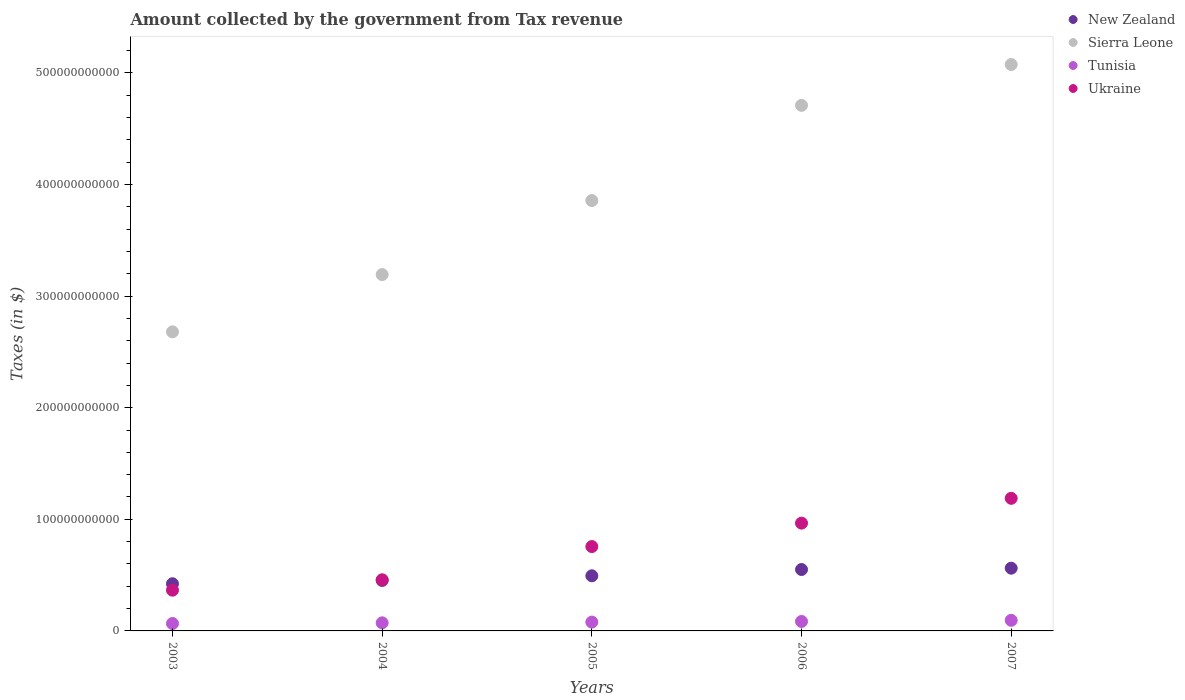How many different coloured dotlines are there?
Ensure brevity in your answer.  4. What is the amount collected by the government from tax revenue in Tunisia in 2005?
Your answer should be very brief. 7.90e+09. Across all years, what is the maximum amount collected by the government from tax revenue in Sierra Leone?
Offer a very short reply. 5.07e+11. Across all years, what is the minimum amount collected by the government from tax revenue in Tunisia?
Provide a succinct answer. 6.63e+09. In which year was the amount collected by the government from tax revenue in Ukraine maximum?
Provide a short and direct response. 2007. What is the total amount collected by the government from tax revenue in Ukraine in the graph?
Your answer should be very brief. 3.73e+11. What is the difference between the amount collected by the government from tax revenue in Sierra Leone in 2003 and that in 2005?
Offer a terse response. -1.18e+11. What is the difference between the amount collected by the government from tax revenue in Tunisia in 2003 and the amount collected by the government from tax revenue in New Zealand in 2007?
Give a very brief answer. -4.96e+1. What is the average amount collected by the government from tax revenue in New Zealand per year?
Keep it short and to the point. 4.96e+1. In the year 2006, what is the difference between the amount collected by the government from tax revenue in Ukraine and amount collected by the government from tax revenue in Tunisia?
Your answer should be compact. 8.81e+1. What is the ratio of the amount collected by the government from tax revenue in Tunisia in 2005 to that in 2006?
Provide a short and direct response. 0.93. Is the amount collected by the government from tax revenue in Sierra Leone in 2006 less than that in 2007?
Make the answer very short. Yes. Is the difference between the amount collected by the government from tax revenue in Ukraine in 2005 and 2007 greater than the difference between the amount collected by the government from tax revenue in Tunisia in 2005 and 2007?
Keep it short and to the point. No. What is the difference between the highest and the second highest amount collected by the government from tax revenue in Ukraine?
Your answer should be compact. 2.22e+1. What is the difference between the highest and the lowest amount collected by the government from tax revenue in New Zealand?
Your answer should be compact. 1.39e+1. In how many years, is the amount collected by the government from tax revenue in Ukraine greater than the average amount collected by the government from tax revenue in Ukraine taken over all years?
Offer a terse response. 3. Is the sum of the amount collected by the government from tax revenue in Tunisia in 2004 and 2005 greater than the maximum amount collected by the government from tax revenue in Sierra Leone across all years?
Provide a succinct answer. No. Is the amount collected by the government from tax revenue in Ukraine strictly greater than the amount collected by the government from tax revenue in Sierra Leone over the years?
Your answer should be very brief. No. How many dotlines are there?
Your answer should be compact. 4. What is the difference between two consecutive major ticks on the Y-axis?
Offer a very short reply. 1.00e+11. Are the values on the major ticks of Y-axis written in scientific E-notation?
Offer a very short reply. No. Does the graph contain any zero values?
Ensure brevity in your answer.  No. Does the graph contain grids?
Provide a succinct answer. No. Where does the legend appear in the graph?
Offer a terse response. Top right. How many legend labels are there?
Offer a terse response. 4. How are the legend labels stacked?
Keep it short and to the point. Vertical. What is the title of the graph?
Your response must be concise. Amount collected by the government from Tax revenue. What is the label or title of the Y-axis?
Make the answer very short. Taxes (in $). What is the Taxes (in $) of New Zealand in 2003?
Ensure brevity in your answer.  4.23e+1. What is the Taxes (in $) of Sierra Leone in 2003?
Offer a very short reply. 2.68e+11. What is the Taxes (in $) of Tunisia in 2003?
Your answer should be very brief. 6.63e+09. What is the Taxes (in $) in Ukraine in 2003?
Your response must be concise. 3.65e+1. What is the Taxes (in $) of New Zealand in 2004?
Provide a succinct answer. 4.52e+1. What is the Taxes (in $) in Sierra Leone in 2004?
Provide a short and direct response. 3.19e+11. What is the Taxes (in $) of Tunisia in 2004?
Your response must be concise. 7.25e+09. What is the Taxes (in $) in Ukraine in 2004?
Give a very brief answer. 4.58e+1. What is the Taxes (in $) of New Zealand in 2005?
Offer a terse response. 4.94e+1. What is the Taxes (in $) of Sierra Leone in 2005?
Your answer should be compact. 3.86e+11. What is the Taxes (in $) in Tunisia in 2005?
Ensure brevity in your answer.  7.90e+09. What is the Taxes (in $) of Ukraine in 2005?
Give a very brief answer. 7.56e+1. What is the Taxes (in $) in New Zealand in 2006?
Keep it short and to the point. 5.50e+1. What is the Taxes (in $) of Sierra Leone in 2006?
Offer a terse response. 4.71e+11. What is the Taxes (in $) in Tunisia in 2006?
Provide a short and direct response. 8.47e+09. What is the Taxes (in $) of Ukraine in 2006?
Offer a very short reply. 9.66e+1. What is the Taxes (in $) in New Zealand in 2007?
Offer a terse response. 5.62e+1. What is the Taxes (in $) in Sierra Leone in 2007?
Keep it short and to the point. 5.07e+11. What is the Taxes (in $) in Tunisia in 2007?
Give a very brief answer. 9.51e+09. What is the Taxes (in $) of Ukraine in 2007?
Ensure brevity in your answer.  1.19e+11. Across all years, what is the maximum Taxes (in $) of New Zealand?
Ensure brevity in your answer.  5.62e+1. Across all years, what is the maximum Taxes (in $) of Sierra Leone?
Your answer should be very brief. 5.07e+11. Across all years, what is the maximum Taxes (in $) of Tunisia?
Offer a very short reply. 9.51e+09. Across all years, what is the maximum Taxes (in $) in Ukraine?
Ensure brevity in your answer.  1.19e+11. Across all years, what is the minimum Taxes (in $) in New Zealand?
Provide a succinct answer. 4.23e+1. Across all years, what is the minimum Taxes (in $) in Sierra Leone?
Provide a succinct answer. 2.68e+11. Across all years, what is the minimum Taxes (in $) of Tunisia?
Offer a very short reply. 6.63e+09. Across all years, what is the minimum Taxes (in $) in Ukraine?
Keep it short and to the point. 3.65e+1. What is the total Taxes (in $) of New Zealand in the graph?
Make the answer very short. 2.48e+11. What is the total Taxes (in $) in Sierra Leone in the graph?
Offer a very short reply. 1.95e+12. What is the total Taxes (in $) in Tunisia in the graph?
Keep it short and to the point. 3.98e+1. What is the total Taxes (in $) of Ukraine in the graph?
Keep it short and to the point. 3.73e+11. What is the difference between the Taxes (in $) in New Zealand in 2003 and that in 2004?
Keep it short and to the point. -2.96e+09. What is the difference between the Taxes (in $) of Sierra Leone in 2003 and that in 2004?
Offer a very short reply. -5.13e+1. What is the difference between the Taxes (in $) of Tunisia in 2003 and that in 2004?
Make the answer very short. -6.21e+08. What is the difference between the Taxes (in $) of Ukraine in 2003 and that in 2004?
Your answer should be very brief. -9.31e+09. What is the difference between the Taxes (in $) of New Zealand in 2003 and that in 2005?
Make the answer very short. -7.13e+09. What is the difference between the Taxes (in $) in Sierra Leone in 2003 and that in 2005?
Make the answer very short. -1.18e+11. What is the difference between the Taxes (in $) of Tunisia in 2003 and that in 2005?
Make the answer very short. -1.27e+09. What is the difference between the Taxes (in $) of Ukraine in 2003 and that in 2005?
Provide a succinct answer. -3.91e+1. What is the difference between the Taxes (in $) of New Zealand in 2003 and that in 2006?
Provide a short and direct response. -1.28e+1. What is the difference between the Taxes (in $) of Sierra Leone in 2003 and that in 2006?
Provide a short and direct response. -2.03e+11. What is the difference between the Taxes (in $) in Tunisia in 2003 and that in 2006?
Give a very brief answer. -1.84e+09. What is the difference between the Taxes (in $) of Ukraine in 2003 and that in 2006?
Offer a very short reply. -6.01e+1. What is the difference between the Taxes (in $) in New Zealand in 2003 and that in 2007?
Keep it short and to the point. -1.39e+1. What is the difference between the Taxes (in $) in Sierra Leone in 2003 and that in 2007?
Ensure brevity in your answer.  -2.40e+11. What is the difference between the Taxes (in $) of Tunisia in 2003 and that in 2007?
Make the answer very short. -2.88e+09. What is the difference between the Taxes (in $) in Ukraine in 2003 and that in 2007?
Offer a terse response. -8.23e+1. What is the difference between the Taxes (in $) in New Zealand in 2004 and that in 2005?
Offer a very short reply. -4.17e+09. What is the difference between the Taxes (in $) of Sierra Leone in 2004 and that in 2005?
Your answer should be very brief. -6.63e+1. What is the difference between the Taxes (in $) in Tunisia in 2004 and that in 2005?
Give a very brief answer. -6.52e+08. What is the difference between the Taxes (in $) of Ukraine in 2004 and that in 2005?
Make the answer very short. -2.98e+1. What is the difference between the Taxes (in $) of New Zealand in 2004 and that in 2006?
Offer a terse response. -9.80e+09. What is the difference between the Taxes (in $) in Sierra Leone in 2004 and that in 2006?
Give a very brief answer. -1.52e+11. What is the difference between the Taxes (in $) of Tunisia in 2004 and that in 2006?
Your answer should be compact. -1.22e+09. What is the difference between the Taxes (in $) of Ukraine in 2004 and that in 2006?
Make the answer very short. -5.08e+1. What is the difference between the Taxes (in $) in New Zealand in 2004 and that in 2007?
Your answer should be compact. -1.10e+1. What is the difference between the Taxes (in $) of Sierra Leone in 2004 and that in 2007?
Make the answer very short. -1.88e+11. What is the difference between the Taxes (in $) of Tunisia in 2004 and that in 2007?
Provide a short and direct response. -2.26e+09. What is the difference between the Taxes (in $) in Ukraine in 2004 and that in 2007?
Provide a succinct answer. -7.30e+1. What is the difference between the Taxes (in $) in New Zealand in 2005 and that in 2006?
Offer a terse response. -5.63e+09. What is the difference between the Taxes (in $) in Sierra Leone in 2005 and that in 2006?
Your answer should be very brief. -8.53e+1. What is the difference between the Taxes (in $) of Tunisia in 2005 and that in 2006?
Keep it short and to the point. -5.66e+08. What is the difference between the Taxes (in $) in Ukraine in 2005 and that in 2006?
Your answer should be very brief. -2.10e+1. What is the difference between the Taxes (in $) of New Zealand in 2005 and that in 2007?
Your answer should be compact. -6.82e+09. What is the difference between the Taxes (in $) of Sierra Leone in 2005 and that in 2007?
Provide a short and direct response. -1.22e+11. What is the difference between the Taxes (in $) in Tunisia in 2005 and that in 2007?
Offer a terse response. -1.60e+09. What is the difference between the Taxes (in $) of Ukraine in 2005 and that in 2007?
Offer a terse response. -4.32e+1. What is the difference between the Taxes (in $) in New Zealand in 2006 and that in 2007?
Make the answer very short. -1.19e+09. What is the difference between the Taxes (in $) in Sierra Leone in 2006 and that in 2007?
Your response must be concise. -3.66e+1. What is the difference between the Taxes (in $) in Tunisia in 2006 and that in 2007?
Ensure brevity in your answer.  -1.04e+09. What is the difference between the Taxes (in $) of Ukraine in 2006 and that in 2007?
Your answer should be compact. -2.22e+1. What is the difference between the Taxes (in $) of New Zealand in 2003 and the Taxes (in $) of Sierra Leone in 2004?
Offer a very short reply. -2.77e+11. What is the difference between the Taxes (in $) in New Zealand in 2003 and the Taxes (in $) in Tunisia in 2004?
Keep it short and to the point. 3.50e+1. What is the difference between the Taxes (in $) of New Zealand in 2003 and the Taxes (in $) of Ukraine in 2004?
Keep it short and to the point. -3.55e+09. What is the difference between the Taxes (in $) in Sierra Leone in 2003 and the Taxes (in $) in Tunisia in 2004?
Your answer should be compact. 2.61e+11. What is the difference between the Taxes (in $) of Sierra Leone in 2003 and the Taxes (in $) of Ukraine in 2004?
Give a very brief answer. 2.22e+11. What is the difference between the Taxes (in $) of Tunisia in 2003 and the Taxes (in $) of Ukraine in 2004?
Make the answer very short. -3.92e+1. What is the difference between the Taxes (in $) of New Zealand in 2003 and the Taxes (in $) of Sierra Leone in 2005?
Keep it short and to the point. -3.43e+11. What is the difference between the Taxes (in $) of New Zealand in 2003 and the Taxes (in $) of Tunisia in 2005?
Ensure brevity in your answer.  3.44e+1. What is the difference between the Taxes (in $) of New Zealand in 2003 and the Taxes (in $) of Ukraine in 2005?
Ensure brevity in your answer.  -3.33e+1. What is the difference between the Taxes (in $) in Sierra Leone in 2003 and the Taxes (in $) in Tunisia in 2005?
Offer a terse response. 2.60e+11. What is the difference between the Taxes (in $) in Sierra Leone in 2003 and the Taxes (in $) in Ukraine in 2005?
Keep it short and to the point. 1.92e+11. What is the difference between the Taxes (in $) in Tunisia in 2003 and the Taxes (in $) in Ukraine in 2005?
Your response must be concise. -6.90e+1. What is the difference between the Taxes (in $) in New Zealand in 2003 and the Taxes (in $) in Sierra Leone in 2006?
Offer a very short reply. -4.29e+11. What is the difference between the Taxes (in $) in New Zealand in 2003 and the Taxes (in $) in Tunisia in 2006?
Offer a very short reply. 3.38e+1. What is the difference between the Taxes (in $) in New Zealand in 2003 and the Taxes (in $) in Ukraine in 2006?
Offer a very short reply. -5.43e+1. What is the difference between the Taxes (in $) in Sierra Leone in 2003 and the Taxes (in $) in Tunisia in 2006?
Ensure brevity in your answer.  2.59e+11. What is the difference between the Taxes (in $) in Sierra Leone in 2003 and the Taxes (in $) in Ukraine in 2006?
Offer a terse response. 1.71e+11. What is the difference between the Taxes (in $) in Tunisia in 2003 and the Taxes (in $) in Ukraine in 2006?
Give a very brief answer. -8.99e+1. What is the difference between the Taxes (in $) of New Zealand in 2003 and the Taxes (in $) of Sierra Leone in 2007?
Offer a terse response. -4.65e+11. What is the difference between the Taxes (in $) of New Zealand in 2003 and the Taxes (in $) of Tunisia in 2007?
Offer a terse response. 3.28e+1. What is the difference between the Taxes (in $) in New Zealand in 2003 and the Taxes (in $) in Ukraine in 2007?
Make the answer very short. -7.65e+1. What is the difference between the Taxes (in $) in Sierra Leone in 2003 and the Taxes (in $) in Tunisia in 2007?
Your answer should be very brief. 2.58e+11. What is the difference between the Taxes (in $) in Sierra Leone in 2003 and the Taxes (in $) in Ukraine in 2007?
Keep it short and to the point. 1.49e+11. What is the difference between the Taxes (in $) of Tunisia in 2003 and the Taxes (in $) of Ukraine in 2007?
Provide a short and direct response. -1.12e+11. What is the difference between the Taxes (in $) of New Zealand in 2004 and the Taxes (in $) of Sierra Leone in 2005?
Ensure brevity in your answer.  -3.40e+11. What is the difference between the Taxes (in $) of New Zealand in 2004 and the Taxes (in $) of Tunisia in 2005?
Your answer should be compact. 3.73e+1. What is the difference between the Taxes (in $) of New Zealand in 2004 and the Taxes (in $) of Ukraine in 2005?
Give a very brief answer. -3.04e+1. What is the difference between the Taxes (in $) in Sierra Leone in 2004 and the Taxes (in $) in Tunisia in 2005?
Offer a very short reply. 3.11e+11. What is the difference between the Taxes (in $) of Sierra Leone in 2004 and the Taxes (in $) of Ukraine in 2005?
Provide a succinct answer. 2.44e+11. What is the difference between the Taxes (in $) in Tunisia in 2004 and the Taxes (in $) in Ukraine in 2005?
Give a very brief answer. -6.83e+1. What is the difference between the Taxes (in $) in New Zealand in 2004 and the Taxes (in $) in Sierra Leone in 2006?
Make the answer very short. -4.26e+11. What is the difference between the Taxes (in $) of New Zealand in 2004 and the Taxes (in $) of Tunisia in 2006?
Offer a very short reply. 3.68e+1. What is the difference between the Taxes (in $) of New Zealand in 2004 and the Taxes (in $) of Ukraine in 2006?
Give a very brief answer. -5.14e+1. What is the difference between the Taxes (in $) of Sierra Leone in 2004 and the Taxes (in $) of Tunisia in 2006?
Make the answer very short. 3.11e+11. What is the difference between the Taxes (in $) in Sierra Leone in 2004 and the Taxes (in $) in Ukraine in 2006?
Your answer should be very brief. 2.23e+11. What is the difference between the Taxes (in $) of Tunisia in 2004 and the Taxes (in $) of Ukraine in 2006?
Your answer should be very brief. -8.93e+1. What is the difference between the Taxes (in $) of New Zealand in 2004 and the Taxes (in $) of Sierra Leone in 2007?
Give a very brief answer. -4.62e+11. What is the difference between the Taxes (in $) of New Zealand in 2004 and the Taxes (in $) of Tunisia in 2007?
Your answer should be compact. 3.57e+1. What is the difference between the Taxes (in $) of New Zealand in 2004 and the Taxes (in $) of Ukraine in 2007?
Offer a terse response. -7.36e+1. What is the difference between the Taxes (in $) in Sierra Leone in 2004 and the Taxes (in $) in Tunisia in 2007?
Ensure brevity in your answer.  3.10e+11. What is the difference between the Taxes (in $) of Sierra Leone in 2004 and the Taxes (in $) of Ukraine in 2007?
Your answer should be very brief. 2.00e+11. What is the difference between the Taxes (in $) in Tunisia in 2004 and the Taxes (in $) in Ukraine in 2007?
Give a very brief answer. -1.12e+11. What is the difference between the Taxes (in $) of New Zealand in 2005 and the Taxes (in $) of Sierra Leone in 2006?
Make the answer very short. -4.22e+11. What is the difference between the Taxes (in $) of New Zealand in 2005 and the Taxes (in $) of Tunisia in 2006?
Your answer should be compact. 4.09e+1. What is the difference between the Taxes (in $) of New Zealand in 2005 and the Taxes (in $) of Ukraine in 2006?
Ensure brevity in your answer.  -4.72e+1. What is the difference between the Taxes (in $) in Sierra Leone in 2005 and the Taxes (in $) in Tunisia in 2006?
Your response must be concise. 3.77e+11. What is the difference between the Taxes (in $) of Sierra Leone in 2005 and the Taxes (in $) of Ukraine in 2006?
Make the answer very short. 2.89e+11. What is the difference between the Taxes (in $) in Tunisia in 2005 and the Taxes (in $) in Ukraine in 2006?
Offer a very short reply. -8.87e+1. What is the difference between the Taxes (in $) of New Zealand in 2005 and the Taxes (in $) of Sierra Leone in 2007?
Offer a very short reply. -4.58e+11. What is the difference between the Taxes (in $) in New Zealand in 2005 and the Taxes (in $) in Tunisia in 2007?
Provide a succinct answer. 3.99e+1. What is the difference between the Taxes (in $) of New Zealand in 2005 and the Taxes (in $) of Ukraine in 2007?
Your answer should be compact. -6.94e+1. What is the difference between the Taxes (in $) of Sierra Leone in 2005 and the Taxes (in $) of Tunisia in 2007?
Make the answer very short. 3.76e+11. What is the difference between the Taxes (in $) of Sierra Leone in 2005 and the Taxes (in $) of Ukraine in 2007?
Offer a terse response. 2.67e+11. What is the difference between the Taxes (in $) of Tunisia in 2005 and the Taxes (in $) of Ukraine in 2007?
Keep it short and to the point. -1.11e+11. What is the difference between the Taxes (in $) of New Zealand in 2006 and the Taxes (in $) of Sierra Leone in 2007?
Ensure brevity in your answer.  -4.52e+11. What is the difference between the Taxes (in $) in New Zealand in 2006 and the Taxes (in $) in Tunisia in 2007?
Provide a short and direct response. 4.55e+1. What is the difference between the Taxes (in $) of New Zealand in 2006 and the Taxes (in $) of Ukraine in 2007?
Your answer should be compact. -6.38e+1. What is the difference between the Taxes (in $) in Sierra Leone in 2006 and the Taxes (in $) in Tunisia in 2007?
Ensure brevity in your answer.  4.61e+11. What is the difference between the Taxes (in $) in Sierra Leone in 2006 and the Taxes (in $) in Ukraine in 2007?
Offer a very short reply. 3.52e+11. What is the difference between the Taxes (in $) of Tunisia in 2006 and the Taxes (in $) of Ukraine in 2007?
Give a very brief answer. -1.10e+11. What is the average Taxes (in $) of New Zealand per year?
Give a very brief answer. 4.96e+1. What is the average Taxes (in $) of Sierra Leone per year?
Your answer should be compact. 3.90e+11. What is the average Taxes (in $) in Tunisia per year?
Keep it short and to the point. 7.95e+09. What is the average Taxes (in $) of Ukraine per year?
Your response must be concise. 7.47e+1. In the year 2003, what is the difference between the Taxes (in $) in New Zealand and Taxes (in $) in Sierra Leone?
Give a very brief answer. -2.26e+11. In the year 2003, what is the difference between the Taxes (in $) of New Zealand and Taxes (in $) of Tunisia?
Make the answer very short. 3.56e+1. In the year 2003, what is the difference between the Taxes (in $) in New Zealand and Taxes (in $) in Ukraine?
Keep it short and to the point. 5.76e+09. In the year 2003, what is the difference between the Taxes (in $) of Sierra Leone and Taxes (in $) of Tunisia?
Ensure brevity in your answer.  2.61e+11. In the year 2003, what is the difference between the Taxes (in $) of Sierra Leone and Taxes (in $) of Ukraine?
Offer a terse response. 2.31e+11. In the year 2003, what is the difference between the Taxes (in $) of Tunisia and Taxes (in $) of Ukraine?
Ensure brevity in your answer.  -2.99e+1. In the year 2004, what is the difference between the Taxes (in $) of New Zealand and Taxes (in $) of Sierra Leone?
Your answer should be very brief. -2.74e+11. In the year 2004, what is the difference between the Taxes (in $) of New Zealand and Taxes (in $) of Tunisia?
Keep it short and to the point. 3.80e+1. In the year 2004, what is the difference between the Taxes (in $) of New Zealand and Taxes (in $) of Ukraine?
Provide a succinct answer. -5.95e+08. In the year 2004, what is the difference between the Taxes (in $) of Sierra Leone and Taxes (in $) of Tunisia?
Give a very brief answer. 3.12e+11. In the year 2004, what is the difference between the Taxes (in $) in Sierra Leone and Taxes (in $) in Ukraine?
Your response must be concise. 2.73e+11. In the year 2004, what is the difference between the Taxes (in $) in Tunisia and Taxes (in $) in Ukraine?
Offer a very short reply. -3.86e+1. In the year 2005, what is the difference between the Taxes (in $) of New Zealand and Taxes (in $) of Sierra Leone?
Provide a short and direct response. -3.36e+11. In the year 2005, what is the difference between the Taxes (in $) of New Zealand and Taxes (in $) of Tunisia?
Offer a terse response. 4.15e+1. In the year 2005, what is the difference between the Taxes (in $) of New Zealand and Taxes (in $) of Ukraine?
Make the answer very short. -2.62e+1. In the year 2005, what is the difference between the Taxes (in $) in Sierra Leone and Taxes (in $) in Tunisia?
Make the answer very short. 3.78e+11. In the year 2005, what is the difference between the Taxes (in $) of Sierra Leone and Taxes (in $) of Ukraine?
Offer a very short reply. 3.10e+11. In the year 2005, what is the difference between the Taxes (in $) in Tunisia and Taxes (in $) in Ukraine?
Offer a terse response. -6.77e+1. In the year 2006, what is the difference between the Taxes (in $) in New Zealand and Taxes (in $) in Sierra Leone?
Ensure brevity in your answer.  -4.16e+11. In the year 2006, what is the difference between the Taxes (in $) of New Zealand and Taxes (in $) of Tunisia?
Provide a succinct answer. 4.65e+1. In the year 2006, what is the difference between the Taxes (in $) in New Zealand and Taxes (in $) in Ukraine?
Your answer should be compact. -4.16e+1. In the year 2006, what is the difference between the Taxes (in $) in Sierra Leone and Taxes (in $) in Tunisia?
Make the answer very short. 4.62e+11. In the year 2006, what is the difference between the Taxes (in $) in Sierra Leone and Taxes (in $) in Ukraine?
Your response must be concise. 3.74e+11. In the year 2006, what is the difference between the Taxes (in $) of Tunisia and Taxes (in $) of Ukraine?
Give a very brief answer. -8.81e+1. In the year 2007, what is the difference between the Taxes (in $) in New Zealand and Taxes (in $) in Sierra Leone?
Your response must be concise. -4.51e+11. In the year 2007, what is the difference between the Taxes (in $) of New Zealand and Taxes (in $) of Tunisia?
Provide a short and direct response. 4.67e+1. In the year 2007, what is the difference between the Taxes (in $) of New Zealand and Taxes (in $) of Ukraine?
Make the answer very short. -6.26e+1. In the year 2007, what is the difference between the Taxes (in $) in Sierra Leone and Taxes (in $) in Tunisia?
Make the answer very short. 4.98e+11. In the year 2007, what is the difference between the Taxes (in $) of Sierra Leone and Taxes (in $) of Ukraine?
Ensure brevity in your answer.  3.89e+11. In the year 2007, what is the difference between the Taxes (in $) in Tunisia and Taxes (in $) in Ukraine?
Your answer should be very brief. -1.09e+11. What is the ratio of the Taxes (in $) of New Zealand in 2003 to that in 2004?
Give a very brief answer. 0.93. What is the ratio of the Taxes (in $) of Sierra Leone in 2003 to that in 2004?
Offer a very short reply. 0.84. What is the ratio of the Taxes (in $) of Tunisia in 2003 to that in 2004?
Make the answer very short. 0.91. What is the ratio of the Taxes (in $) of Ukraine in 2003 to that in 2004?
Keep it short and to the point. 0.8. What is the ratio of the Taxes (in $) in New Zealand in 2003 to that in 2005?
Your answer should be compact. 0.86. What is the ratio of the Taxes (in $) in Sierra Leone in 2003 to that in 2005?
Your answer should be very brief. 0.69. What is the ratio of the Taxes (in $) in Tunisia in 2003 to that in 2005?
Provide a succinct answer. 0.84. What is the ratio of the Taxes (in $) of Ukraine in 2003 to that in 2005?
Provide a succinct answer. 0.48. What is the ratio of the Taxes (in $) in New Zealand in 2003 to that in 2006?
Your answer should be very brief. 0.77. What is the ratio of the Taxes (in $) of Sierra Leone in 2003 to that in 2006?
Make the answer very short. 0.57. What is the ratio of the Taxes (in $) of Tunisia in 2003 to that in 2006?
Offer a terse response. 0.78. What is the ratio of the Taxes (in $) of Ukraine in 2003 to that in 2006?
Your answer should be very brief. 0.38. What is the ratio of the Taxes (in $) of New Zealand in 2003 to that in 2007?
Your answer should be very brief. 0.75. What is the ratio of the Taxes (in $) of Sierra Leone in 2003 to that in 2007?
Offer a terse response. 0.53. What is the ratio of the Taxes (in $) of Tunisia in 2003 to that in 2007?
Offer a very short reply. 0.7. What is the ratio of the Taxes (in $) in Ukraine in 2003 to that in 2007?
Provide a succinct answer. 0.31. What is the ratio of the Taxes (in $) of New Zealand in 2004 to that in 2005?
Your answer should be very brief. 0.92. What is the ratio of the Taxes (in $) in Sierra Leone in 2004 to that in 2005?
Your response must be concise. 0.83. What is the ratio of the Taxes (in $) in Tunisia in 2004 to that in 2005?
Give a very brief answer. 0.92. What is the ratio of the Taxes (in $) of Ukraine in 2004 to that in 2005?
Ensure brevity in your answer.  0.61. What is the ratio of the Taxes (in $) of New Zealand in 2004 to that in 2006?
Offer a very short reply. 0.82. What is the ratio of the Taxes (in $) in Sierra Leone in 2004 to that in 2006?
Provide a succinct answer. 0.68. What is the ratio of the Taxes (in $) in Tunisia in 2004 to that in 2006?
Give a very brief answer. 0.86. What is the ratio of the Taxes (in $) in Ukraine in 2004 to that in 2006?
Provide a succinct answer. 0.47. What is the ratio of the Taxes (in $) in New Zealand in 2004 to that in 2007?
Your answer should be very brief. 0.8. What is the ratio of the Taxes (in $) of Sierra Leone in 2004 to that in 2007?
Your answer should be very brief. 0.63. What is the ratio of the Taxes (in $) of Tunisia in 2004 to that in 2007?
Offer a terse response. 0.76. What is the ratio of the Taxes (in $) in Ukraine in 2004 to that in 2007?
Your answer should be very brief. 0.39. What is the ratio of the Taxes (in $) of New Zealand in 2005 to that in 2006?
Keep it short and to the point. 0.9. What is the ratio of the Taxes (in $) in Sierra Leone in 2005 to that in 2006?
Your response must be concise. 0.82. What is the ratio of the Taxes (in $) in Tunisia in 2005 to that in 2006?
Provide a succinct answer. 0.93. What is the ratio of the Taxes (in $) of Ukraine in 2005 to that in 2006?
Your answer should be very brief. 0.78. What is the ratio of the Taxes (in $) in New Zealand in 2005 to that in 2007?
Offer a very short reply. 0.88. What is the ratio of the Taxes (in $) of Sierra Leone in 2005 to that in 2007?
Offer a terse response. 0.76. What is the ratio of the Taxes (in $) in Tunisia in 2005 to that in 2007?
Your answer should be very brief. 0.83. What is the ratio of the Taxes (in $) of Ukraine in 2005 to that in 2007?
Ensure brevity in your answer.  0.64. What is the ratio of the Taxes (in $) in New Zealand in 2006 to that in 2007?
Your answer should be very brief. 0.98. What is the ratio of the Taxes (in $) of Sierra Leone in 2006 to that in 2007?
Your answer should be very brief. 0.93. What is the ratio of the Taxes (in $) of Tunisia in 2006 to that in 2007?
Provide a short and direct response. 0.89. What is the ratio of the Taxes (in $) of Ukraine in 2006 to that in 2007?
Provide a succinct answer. 0.81. What is the difference between the highest and the second highest Taxes (in $) of New Zealand?
Make the answer very short. 1.19e+09. What is the difference between the highest and the second highest Taxes (in $) in Sierra Leone?
Keep it short and to the point. 3.66e+1. What is the difference between the highest and the second highest Taxes (in $) of Tunisia?
Offer a terse response. 1.04e+09. What is the difference between the highest and the second highest Taxes (in $) of Ukraine?
Ensure brevity in your answer.  2.22e+1. What is the difference between the highest and the lowest Taxes (in $) in New Zealand?
Provide a succinct answer. 1.39e+1. What is the difference between the highest and the lowest Taxes (in $) of Sierra Leone?
Your answer should be compact. 2.40e+11. What is the difference between the highest and the lowest Taxes (in $) of Tunisia?
Provide a short and direct response. 2.88e+09. What is the difference between the highest and the lowest Taxes (in $) of Ukraine?
Give a very brief answer. 8.23e+1. 